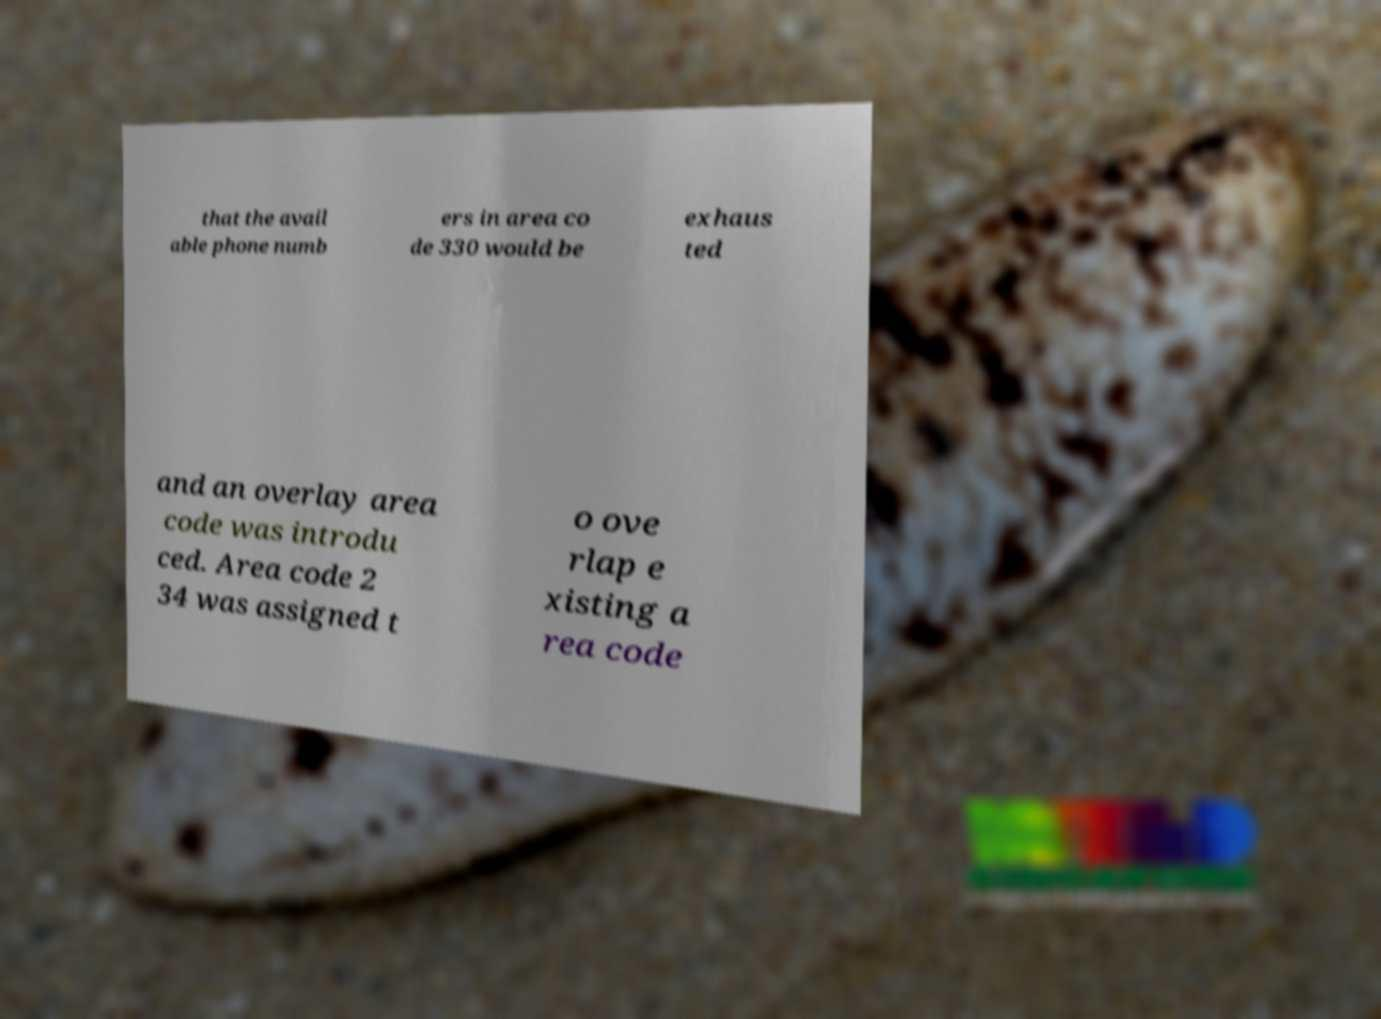Could you extract and type out the text from this image? that the avail able phone numb ers in area co de 330 would be exhaus ted and an overlay area code was introdu ced. Area code 2 34 was assigned t o ove rlap e xisting a rea code 